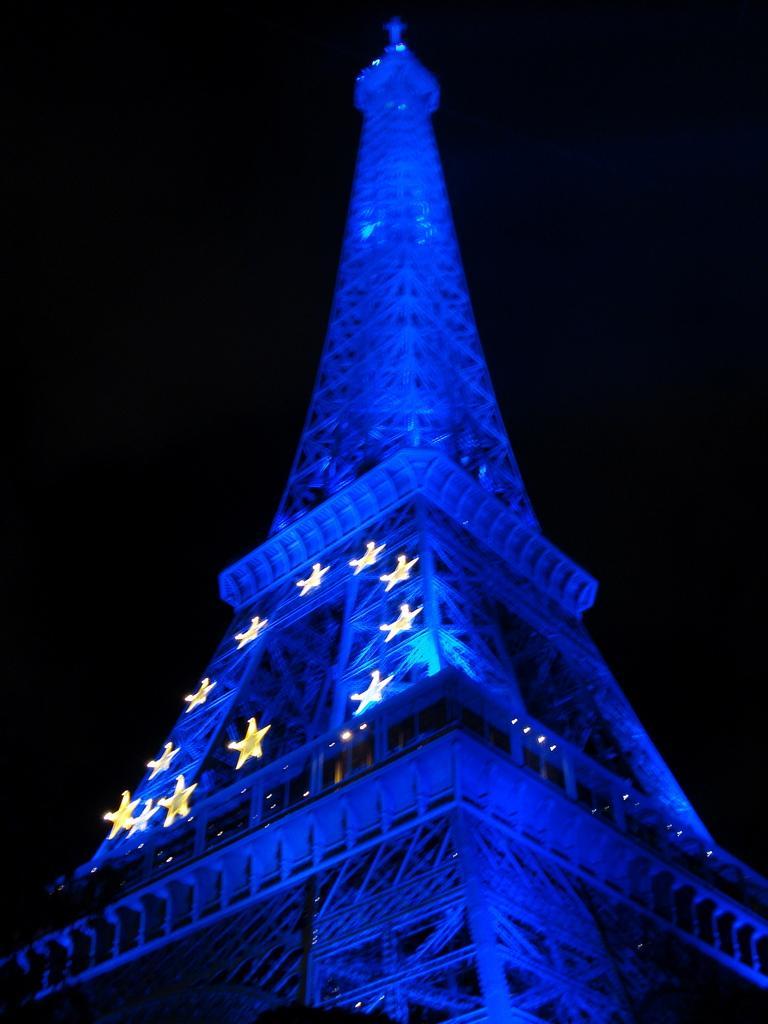Can you describe this image briefly? Here we can see a tower and there is a dark background. 